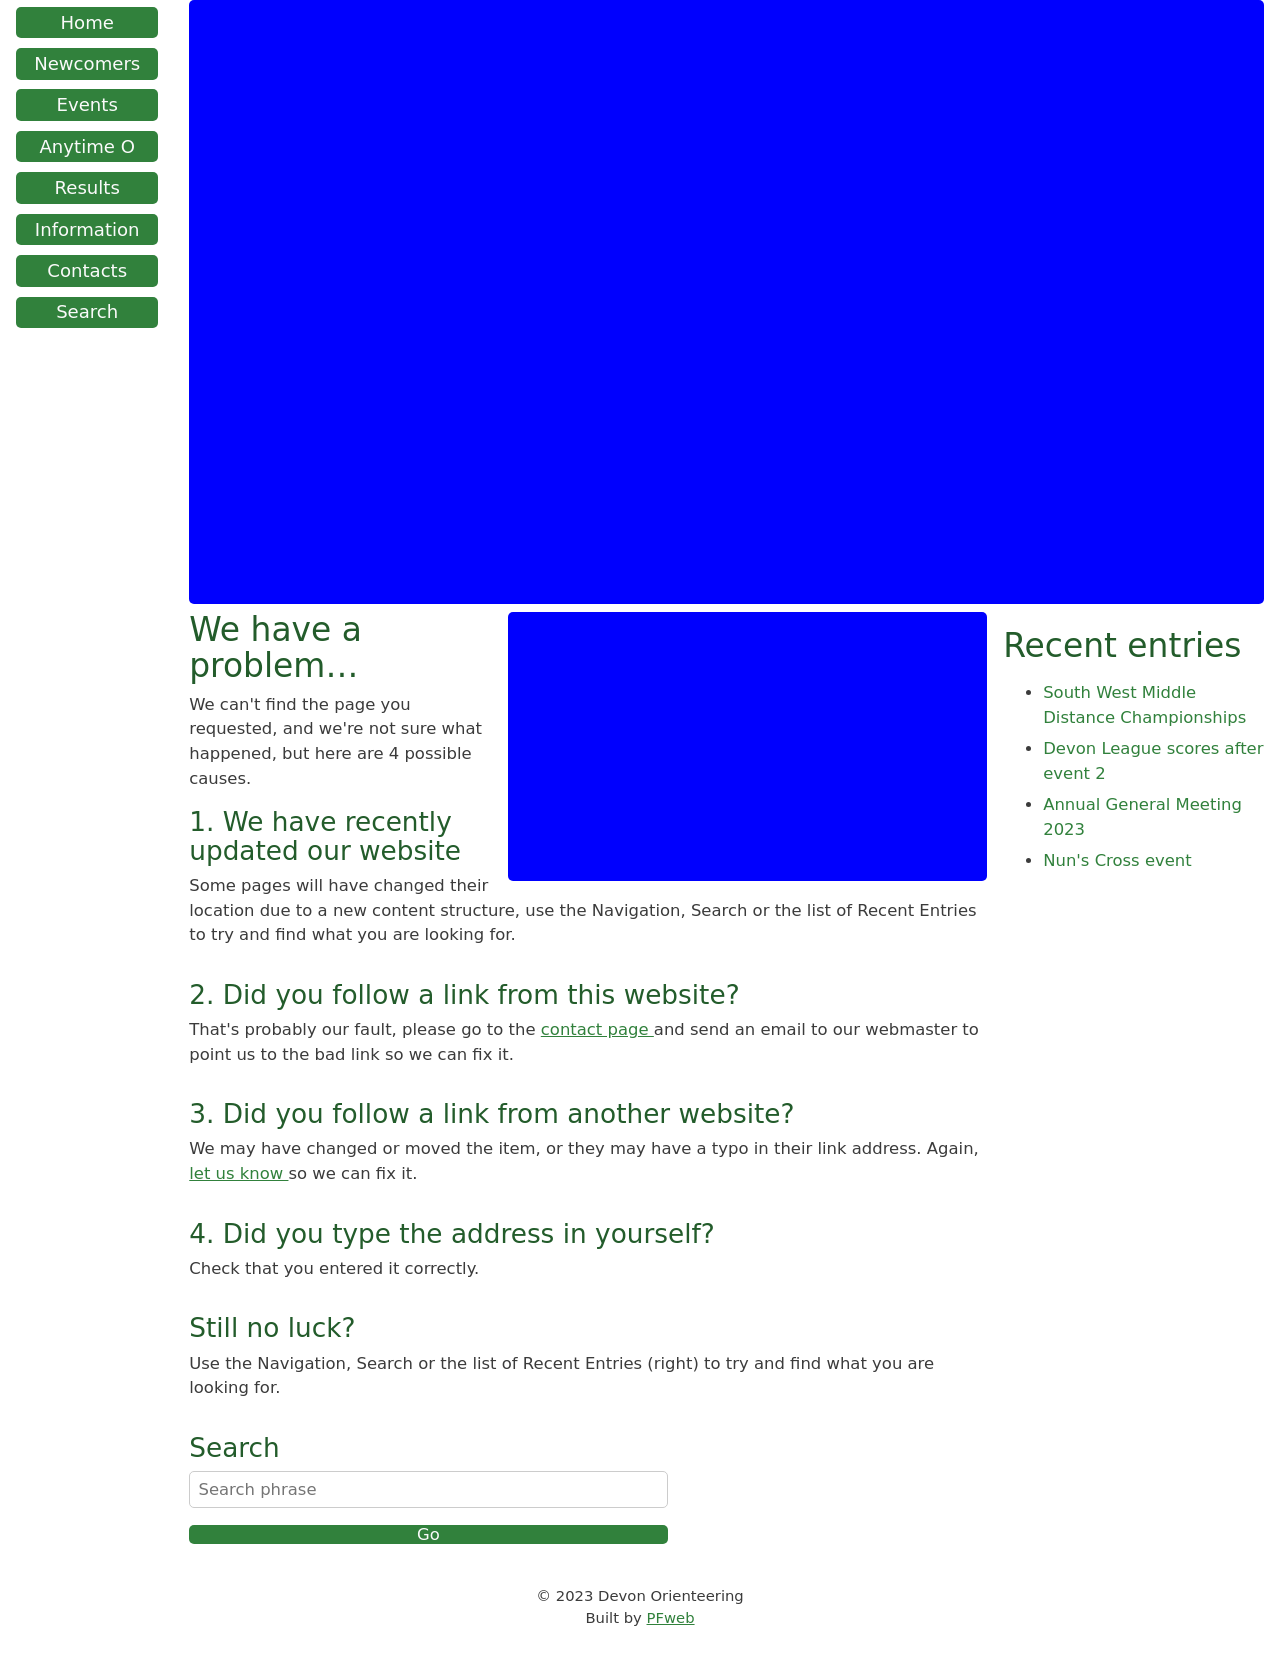How can the design of the error page shown in the image improve the user experience during navigation failures? The design of the error page in the image improves user experience by employing several user-friendly elements: 1. Clear communication stating that there’s a problem with finding the requested page, which helps in setting the right expectations. 2. It lists possible reasons for the error, which aids the user in understanding what might have gone wrong. 3. Suggestions for navigation such as using the search bar, checking recent entries, and a contact link to report issues, which provides users with alternative paths to find their desired content. 4. The layout is simple and clean, focusing the user’s attention directly on solving their navigation issue without getting distracted by excessive design elements. 